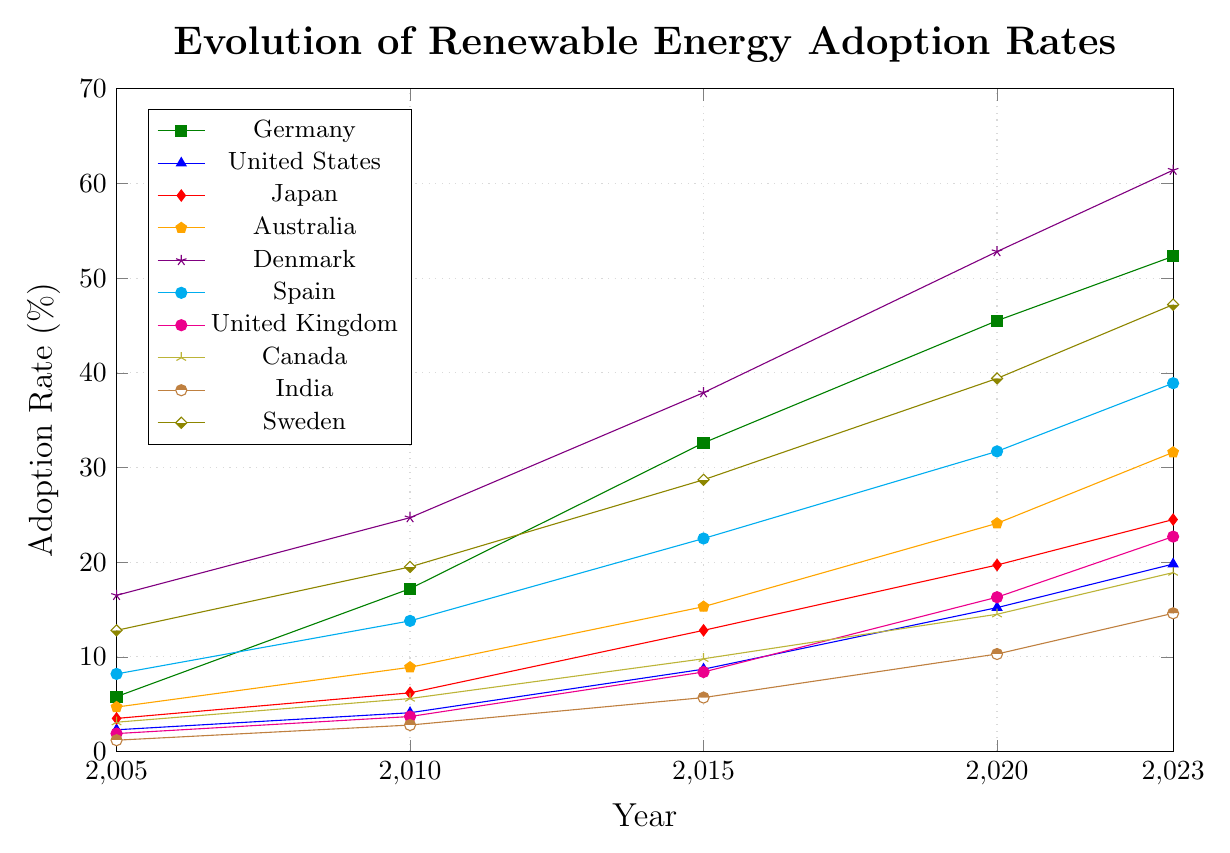What's the general trend of renewable energy adoption rates from 2005 to 2023? The plot shows an overall upward trend in renewable energy adoption rates across all countries. Each country's line consistently rises over time, indicating increased adoption rates from 2005 to 2023.
Answer: Upward trend Which country had the highest adoption rate in 2023 and what was it? From the plot, we can see that Denmark had the highest adoption rate in 2023, with a value that surpasses all other countries in the figure.
Answer: Denmark, 61.4% Between 2010 and 2020, which country showed the largest increase in renewable energy adoption rate? We can calculate the increase for each country by subtracting the 2010 rate from the 2020 rate and then comparing these values. Denmark had the highest increase: 52.8% (2020) - 24.7% (2010) = 28.1%.
Answer: Denmark Compare the adoption rates of Germany and Japan in 2015. Which country had a higher rate and by how much? In 2015, Germany had an adoption rate of 32.6% and Japan had 12.8%. We subtract Japan's rate from Germany's rate: 32.6% - 12.8% = 19.8%.
Answer: Germany, by 19.8% What is the average adoption rate for Canada from 2005 to 2023? To find the average, sum the adoption rates for Canada over the years mentioned and divide by the number of years: (3.1 + 5.6 + 9.8 + 14.5 + 18.9) / 5 = 51.9 / 5 = 10.38%.
Answer: 10.38% Which country had the lowest adoption rate in 2005 and what was the rate? The plot shows that India had the lowest adoption rate in 2005, as indicated by the position of its line relative to others in that year.
Answer: India, 1.2% By how many percentage points did Spain's adoption rate increase from 2005 to 2023? We find the difference between Spain's adoption rates in 2023 and 2005: 38.9% (2023) - 8.2% (2005) = 30.7%.
Answer: 30.7 percentage points Which country had a steeper increase in adoption rates between 2010 and 2015, Australia or United Kingdom? We calculate the increase for both countries over that period: Australia: 15.3% - 8.9% = 6.4%, United Kingdom: 8.4% - 3.7% = 4.7%. Australia's increase is steeper.
Answer: Australia Considering the adoption rates in 2023, what's the ratio of Germany's rate to India’s rate? We divide Germany's rate by India's rate: 52.3% / 14.6% ≈ 3.58.
Answer: 3.58 In which year did Sweden surpass a 30% adoption rate and by how much was it surpassed in that year? From the plot, it shows that Sweden surpassed 30% in 2015 with an adoption rate of 28.7%. By 2020, Sweden had an adoption rate of 39.4%, so it surpassed 30% by 9.4 percentage points.
Answer: 2020, by 9.4 percentage points 